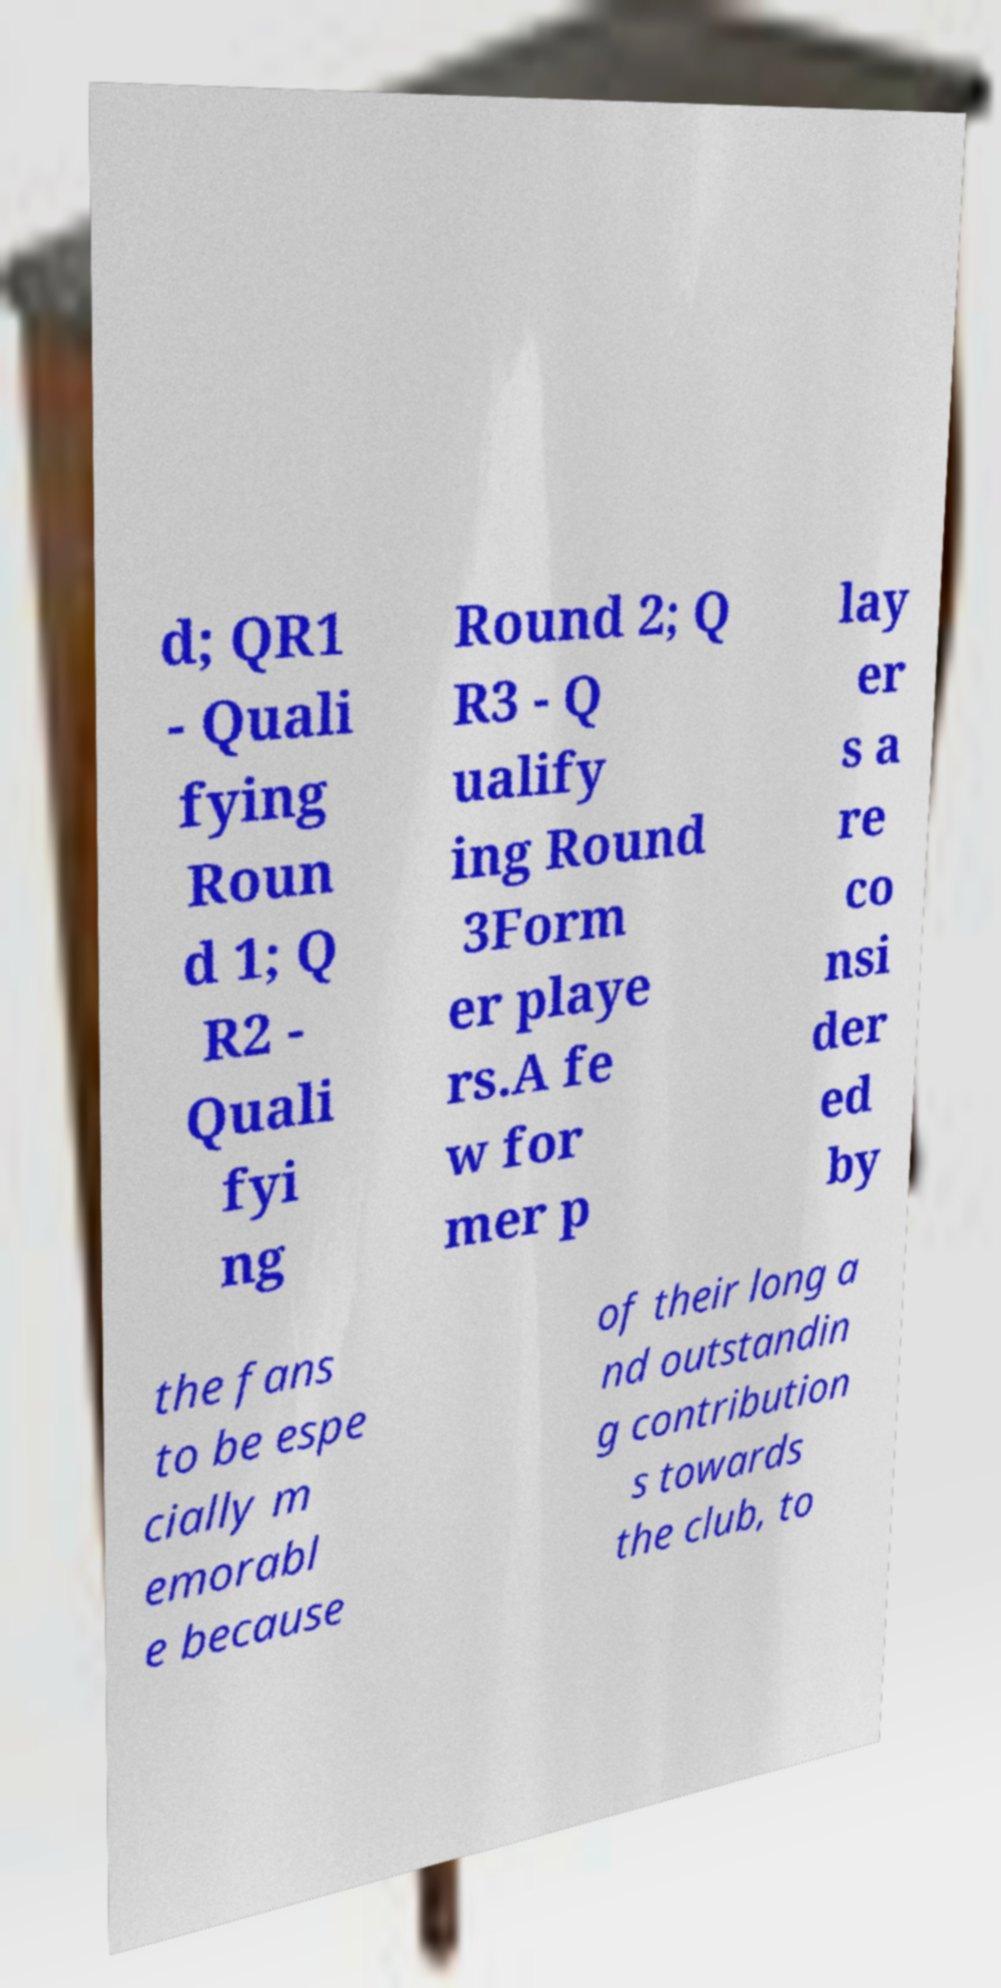For documentation purposes, I need the text within this image transcribed. Could you provide that? d; QR1 - Quali fying Roun d 1; Q R2 - Quali fyi ng Round 2; Q R3 - Q ualify ing Round 3Form er playe rs.A fe w for mer p lay er s a re co nsi der ed by the fans to be espe cially m emorabl e because of their long a nd outstandin g contribution s towards the club, to 